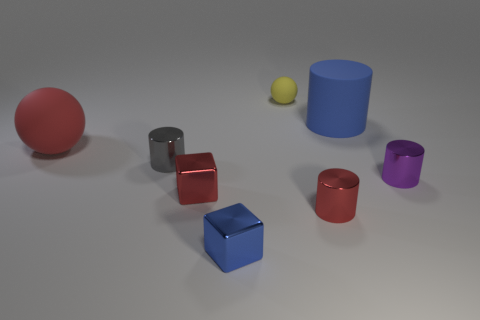There is a gray thing; does it have the same size as the red rubber sphere that is on the left side of the yellow object?
Make the answer very short. No. There is a large rubber thing behind the red rubber ball; what color is it?
Your answer should be very brief. Blue. What number of green objects are blocks or big metal balls?
Your answer should be compact. 0. What is the color of the small sphere?
Your answer should be very brief. Yellow. Is there any other thing that is made of the same material as the big red object?
Make the answer very short. Yes. Are there fewer tiny blue blocks that are behind the purple cylinder than big red rubber spheres to the left of the big red rubber thing?
Provide a short and direct response. No. There is a object that is on the left side of the small matte thing and behind the gray cylinder; what is its shape?
Keep it short and to the point. Sphere. What number of other small gray shiny things are the same shape as the gray thing?
Provide a succinct answer. 0. There is a red ball that is the same material as the yellow thing; what is its size?
Your response must be concise. Large. What number of blue metal blocks are the same size as the blue rubber cylinder?
Ensure brevity in your answer.  0. 